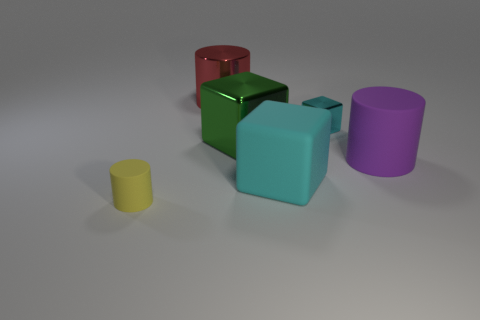There is a thing that is the same color as the big rubber cube; what is its size?
Your answer should be compact. Small. There is a large block that is the same color as the tiny block; what is it made of?
Offer a terse response. Rubber. How big is the matte cylinder to the left of the small cyan thing?
Make the answer very short. Small. Is there a large red sphere that has the same material as the yellow cylinder?
Provide a succinct answer. No. What number of green objects are the same shape as the large red thing?
Your answer should be very brief. 0. What is the shape of the tiny thing that is to the right of the matte cylinder that is to the left of the large rubber thing in front of the big purple matte cylinder?
Your response must be concise. Cube. There is a big thing that is left of the big cyan matte thing and in front of the tiny cyan metallic cube; what material is it?
Ensure brevity in your answer.  Metal. Is the size of the cylinder behind the cyan shiny thing the same as the tiny yellow cylinder?
Your answer should be compact. No. Is the number of big objects on the left side of the green cube greater than the number of yellow objects that are right of the matte cube?
Give a very brief answer. Yes. The small object that is in front of the block that is to the right of the large block that is to the right of the green block is what color?
Your answer should be compact. Yellow. 